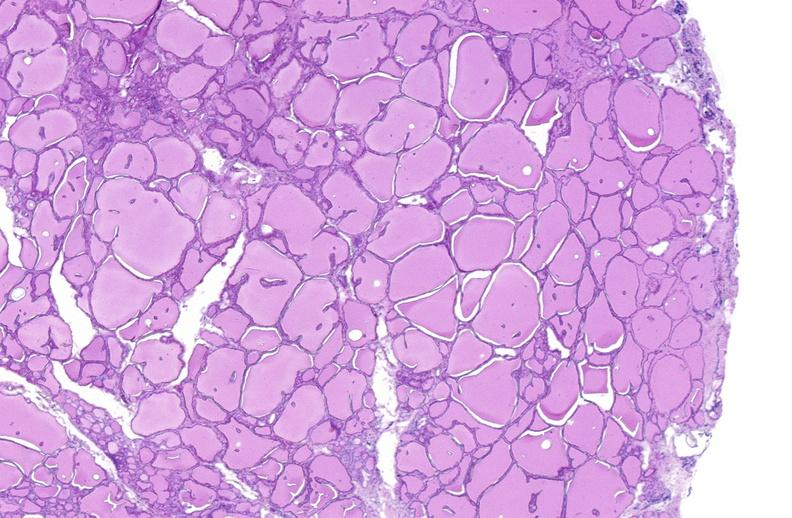s intraductal papillomatosis with apocrine metaplasia present?
Answer the question using a single word or phrase. No 